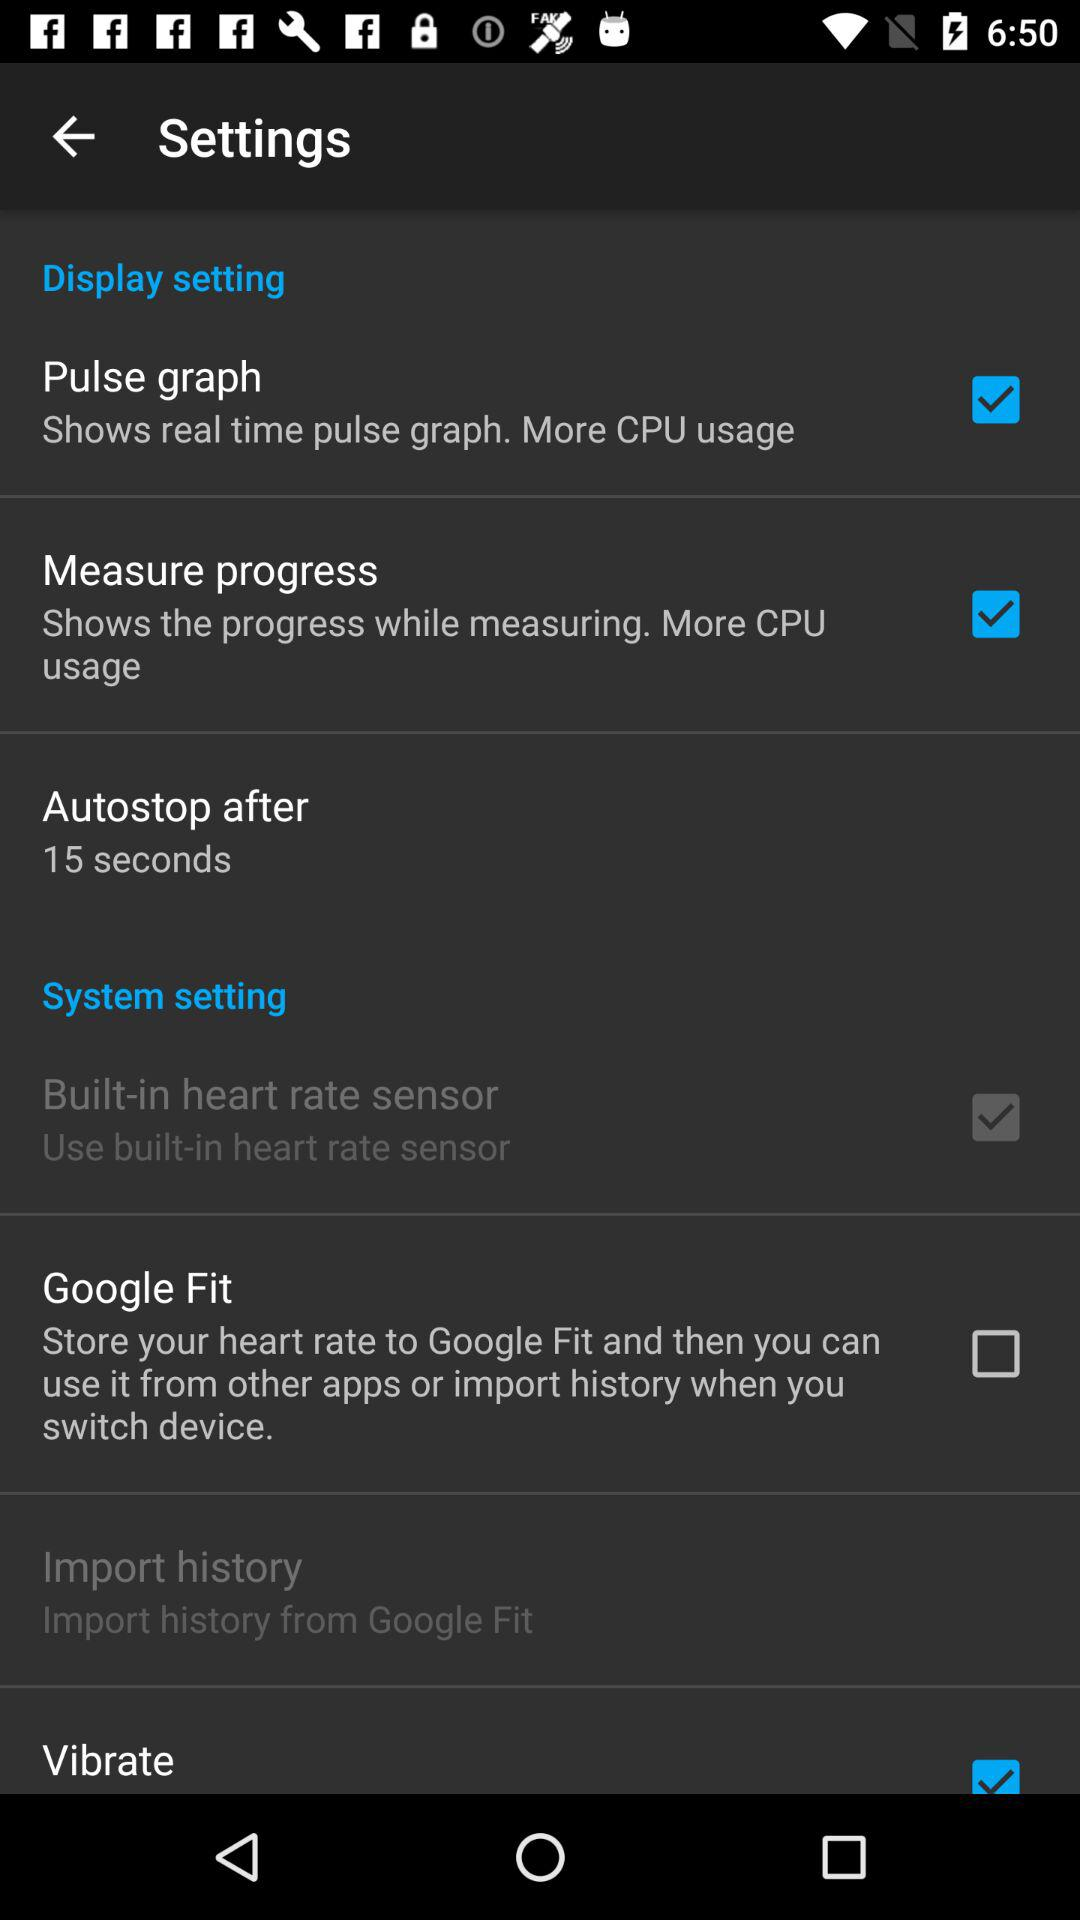Which settings are unchecked? The unchecked setting is "Google Fit". 